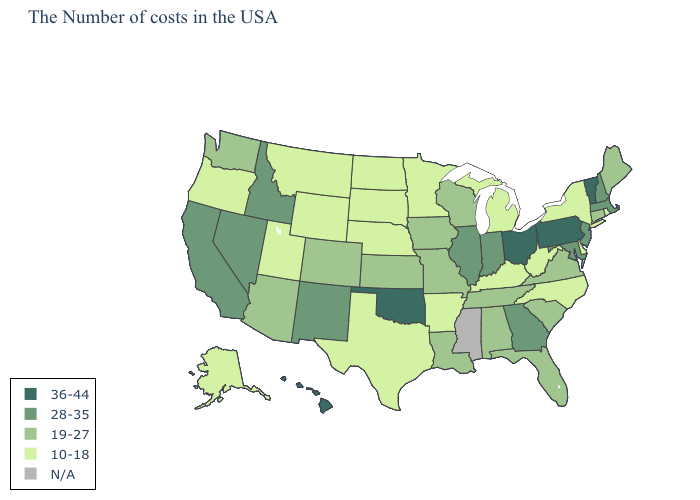Name the states that have a value in the range N/A?
Give a very brief answer. Mississippi. Name the states that have a value in the range 10-18?
Quick response, please. Rhode Island, New York, Delaware, North Carolina, West Virginia, Michigan, Kentucky, Arkansas, Minnesota, Nebraska, Texas, South Dakota, North Dakota, Wyoming, Utah, Montana, Oregon, Alaska. Name the states that have a value in the range 10-18?
Quick response, please. Rhode Island, New York, Delaware, North Carolina, West Virginia, Michigan, Kentucky, Arkansas, Minnesota, Nebraska, Texas, South Dakota, North Dakota, Wyoming, Utah, Montana, Oregon, Alaska. Does Ohio have the highest value in the USA?
Quick response, please. Yes. What is the lowest value in the MidWest?
Keep it brief. 10-18. Among the states that border South Carolina , which have the highest value?
Answer briefly. Georgia. Name the states that have a value in the range 36-44?
Quick response, please. Vermont, Pennsylvania, Ohio, Oklahoma, Hawaii. What is the highest value in the USA?
Short answer required. 36-44. Does New Hampshire have the highest value in the USA?
Give a very brief answer. No. Name the states that have a value in the range 10-18?
Write a very short answer. Rhode Island, New York, Delaware, North Carolina, West Virginia, Michigan, Kentucky, Arkansas, Minnesota, Nebraska, Texas, South Dakota, North Dakota, Wyoming, Utah, Montana, Oregon, Alaska. What is the highest value in the Northeast ?
Short answer required. 36-44. What is the value of California?
Give a very brief answer. 28-35. What is the value of Florida?
Write a very short answer. 19-27. 